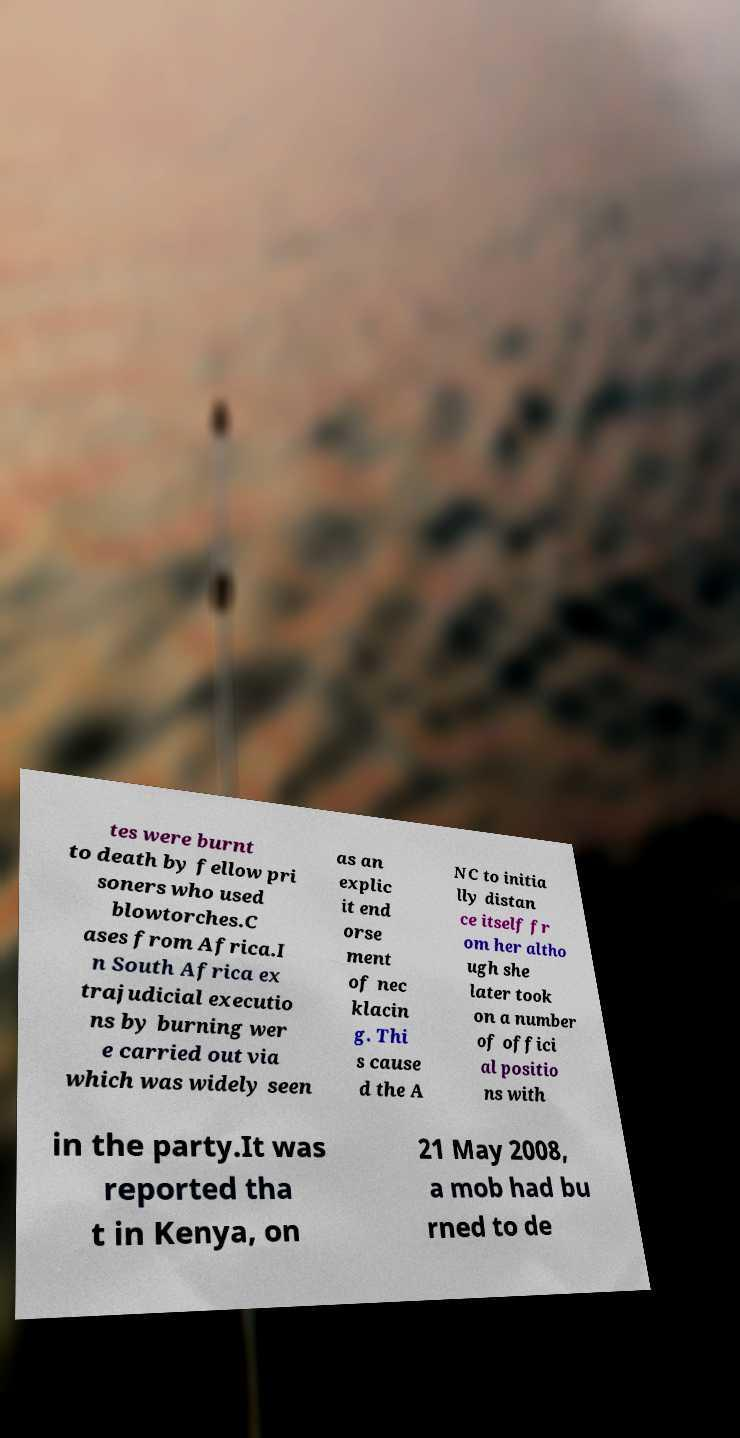There's text embedded in this image that I need extracted. Can you transcribe it verbatim? tes were burnt to death by fellow pri soners who used blowtorches.C ases from Africa.I n South Africa ex trajudicial executio ns by burning wer e carried out via which was widely seen as an explic it end orse ment of nec klacin g. Thi s cause d the A NC to initia lly distan ce itself fr om her altho ugh she later took on a number of offici al positio ns with in the party.It was reported tha t in Kenya, on 21 May 2008, a mob had bu rned to de 